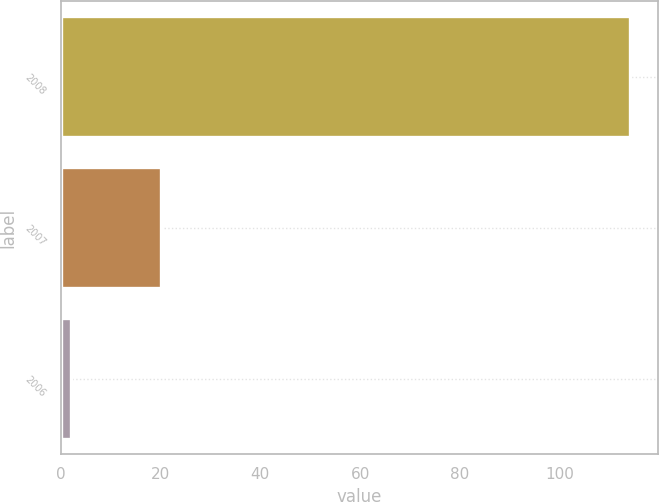Convert chart to OTSL. <chart><loc_0><loc_0><loc_500><loc_500><bar_chart><fcel>2008<fcel>2007<fcel>2006<nl><fcel>114<fcel>20<fcel>2<nl></chart> 